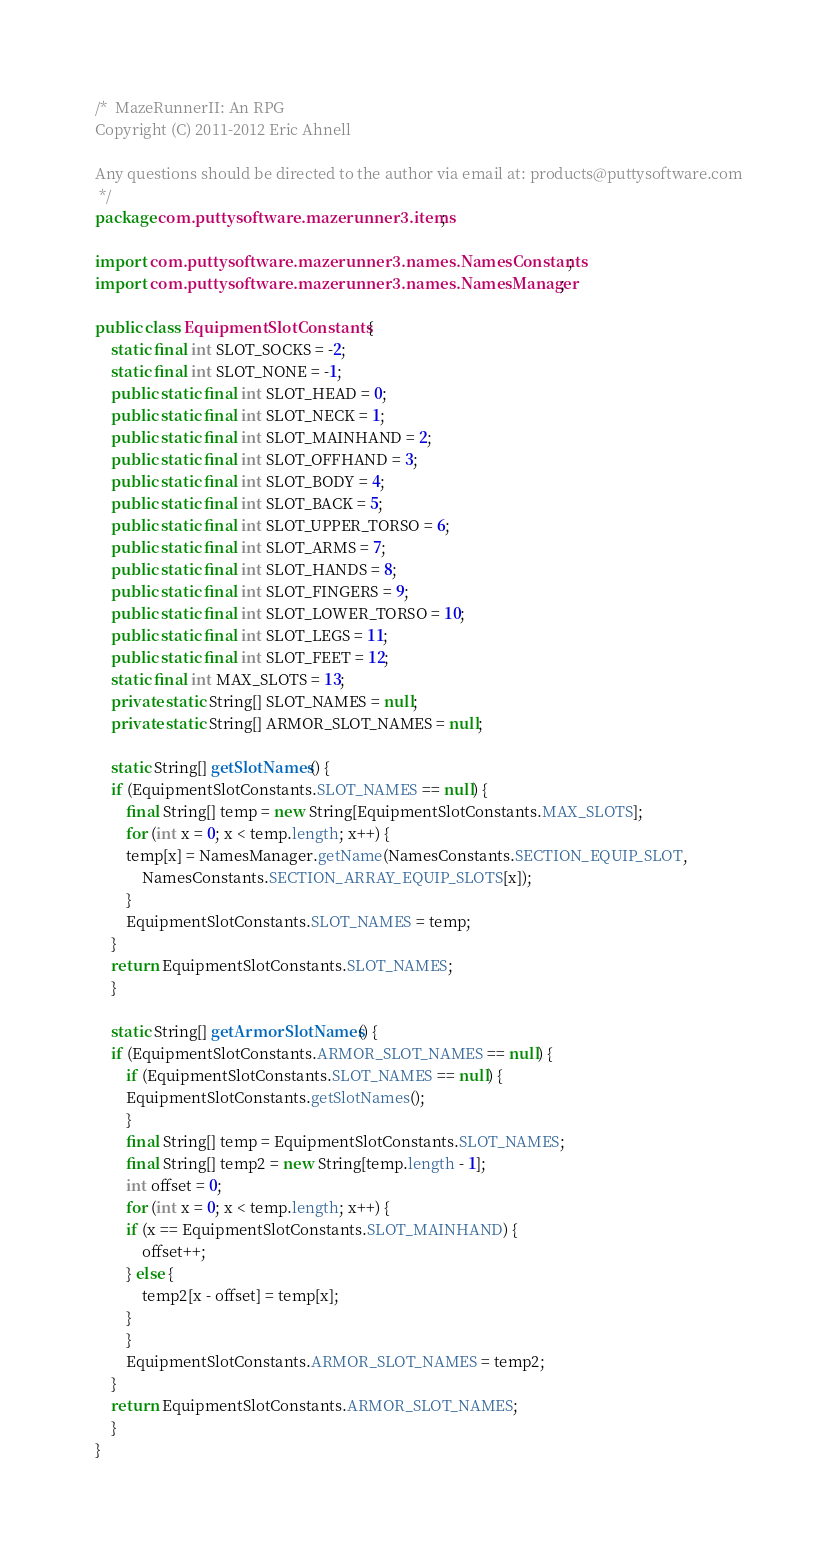<code> <loc_0><loc_0><loc_500><loc_500><_Java_>/*  MazeRunnerII: An RPG
Copyright (C) 2011-2012 Eric Ahnell

Any questions should be directed to the author via email at: products@puttysoftware.com
 */
package com.puttysoftware.mazerunner3.items;

import com.puttysoftware.mazerunner3.names.NamesConstants;
import com.puttysoftware.mazerunner3.names.NamesManager;

public class EquipmentSlotConstants {
    static final int SLOT_SOCKS = -2;
    static final int SLOT_NONE = -1;
    public static final int SLOT_HEAD = 0;
    public static final int SLOT_NECK = 1;
    public static final int SLOT_MAINHAND = 2;
    public static final int SLOT_OFFHAND = 3;
    public static final int SLOT_BODY = 4;
    public static final int SLOT_BACK = 5;
    public static final int SLOT_UPPER_TORSO = 6;
    public static final int SLOT_ARMS = 7;
    public static final int SLOT_HANDS = 8;
    public static final int SLOT_FINGERS = 9;
    public static final int SLOT_LOWER_TORSO = 10;
    public static final int SLOT_LEGS = 11;
    public static final int SLOT_FEET = 12;
    static final int MAX_SLOTS = 13;
    private static String[] SLOT_NAMES = null;
    private static String[] ARMOR_SLOT_NAMES = null;

    static String[] getSlotNames() {
	if (EquipmentSlotConstants.SLOT_NAMES == null) {
	    final String[] temp = new String[EquipmentSlotConstants.MAX_SLOTS];
	    for (int x = 0; x < temp.length; x++) {
		temp[x] = NamesManager.getName(NamesConstants.SECTION_EQUIP_SLOT,
			NamesConstants.SECTION_ARRAY_EQUIP_SLOTS[x]);
	    }
	    EquipmentSlotConstants.SLOT_NAMES = temp;
	}
	return EquipmentSlotConstants.SLOT_NAMES;
    }

    static String[] getArmorSlotNames() {
	if (EquipmentSlotConstants.ARMOR_SLOT_NAMES == null) {
	    if (EquipmentSlotConstants.SLOT_NAMES == null) {
		EquipmentSlotConstants.getSlotNames();
	    }
	    final String[] temp = EquipmentSlotConstants.SLOT_NAMES;
	    final String[] temp2 = new String[temp.length - 1];
	    int offset = 0;
	    for (int x = 0; x < temp.length; x++) {
		if (x == EquipmentSlotConstants.SLOT_MAINHAND) {
		    offset++;
		} else {
		    temp2[x - offset] = temp[x];
		}
	    }
	    EquipmentSlotConstants.ARMOR_SLOT_NAMES = temp2;
	}
	return EquipmentSlotConstants.ARMOR_SLOT_NAMES;
    }
}
</code> 